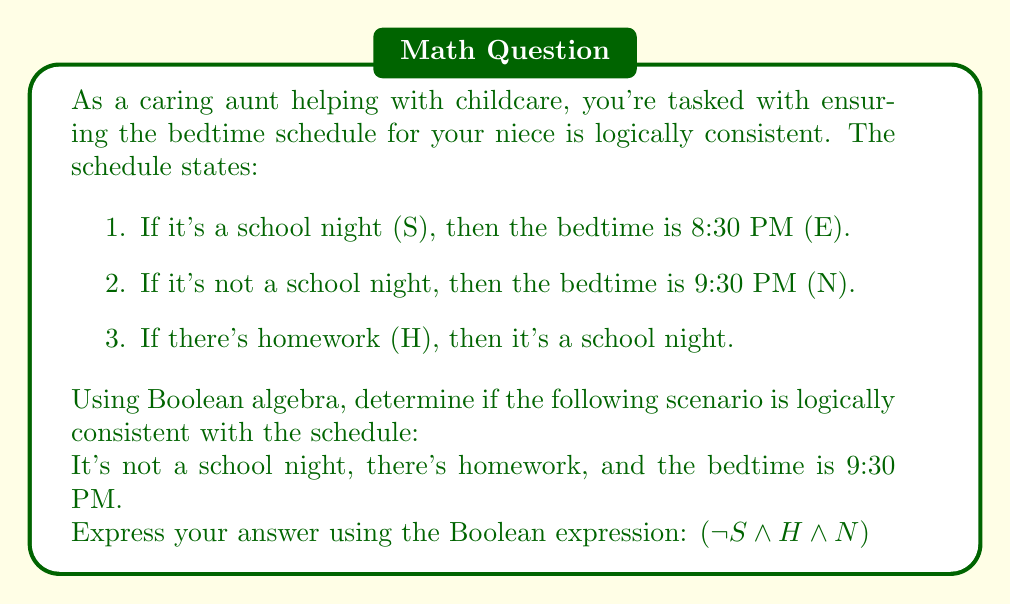Teach me how to tackle this problem. Let's break this down step-by-step using Boolean algebra:

1. Given statements in Boolean form:
   - $S \rightarrow E$ (If school night, then 8:30 PM bedtime)
   - $\neg S \rightarrow N$ (If not school night, then 9:30 PM bedtime)
   - $H \rightarrow S$ (If homework, then school night)

2. The scenario gives us:
   $\neg S \land H \land N$

3. Let's evaluate the consistency:
   - $\neg S$ is given, which satisfies the second rule.
   - $H$ is given, which according to the third rule implies $S$.
   - But we have $\neg S$, which contradicts $H \rightarrow S$.

4. This contradiction can be shown formally:
   $$\begin{align}
   (\neg S \land H) &\rightarrow (H \land \neg S) \\
   &\rightarrow (S \land \neg S) \text{ (because } H \rightarrow S\text{)} \\
   &\rightarrow \text{False}
   \end{align}$$

5. Since we derived a contradiction, the given scenario $(\neg S \land H \land N)$ is not logically consistent with the bedtime schedule rules.
Answer: False 